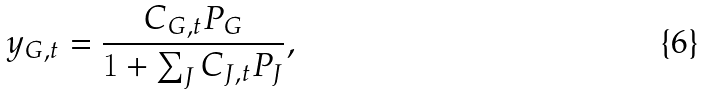Convert formula to latex. <formula><loc_0><loc_0><loc_500><loc_500>y _ { G , t } = \frac { C _ { G , t } P _ { G } } { 1 + \sum _ { J } C _ { J , t } P _ { J } } ,</formula> 